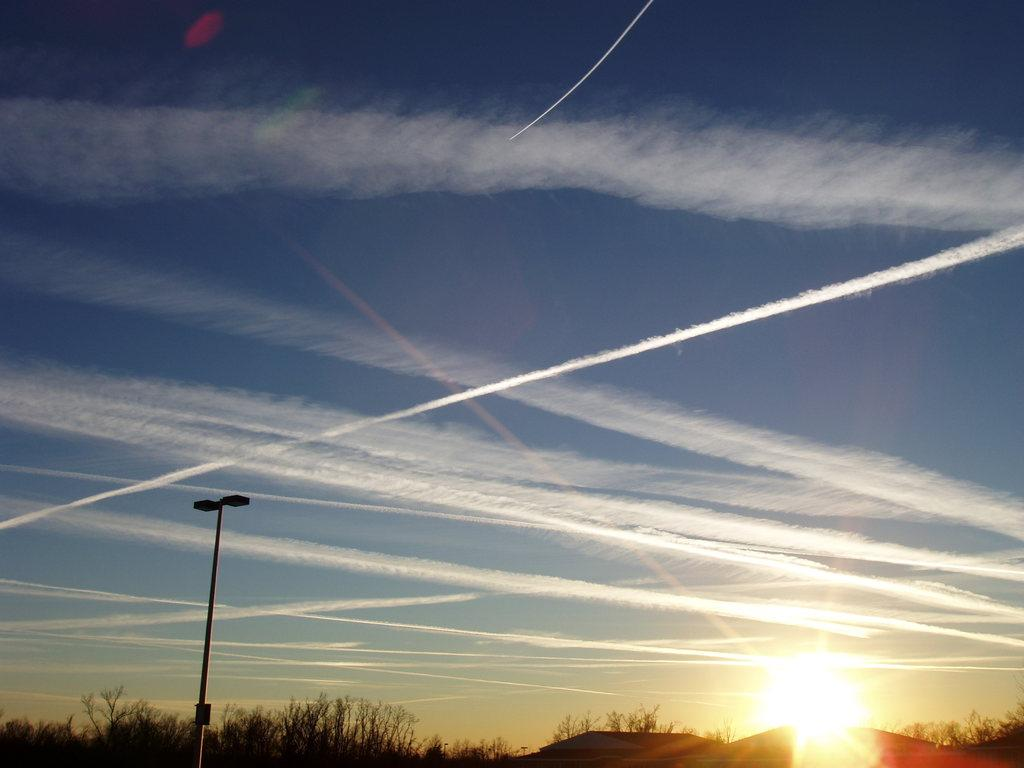What is the main object in the image? There is a pole in the image. What other objects can be seen in the image? There are trees in the image. What can be seen in the background of the image? The sky is visible in the background of the image. What word is written on the pole in the image? There is no word written on the pole in the image. How many seats are visible in the image? There are no seats present in the image. 